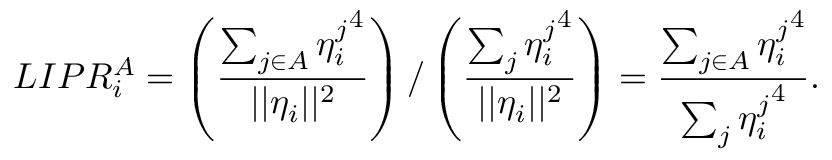Convert formula to latex. <formula><loc_0><loc_0><loc_500><loc_500>L I P R _ { i } ^ { A } = \left ( \frac { \sum _ { j \in A } { \eta _ { i } ^ { j } } ^ { 4 } } { | | \eta _ { i } | | ^ { 2 } } \right ) / \left ( \frac { \sum _ { j } { \eta _ { i } ^ { j } } ^ { 4 } } { | | \eta _ { i } | | ^ { 2 } } \right ) = \frac { \sum _ { j \in A } { \eta _ { i } ^ { j } } ^ { 4 } } { \sum _ { j } { \eta _ { i } ^ { j } } ^ { 4 } } .</formula> 